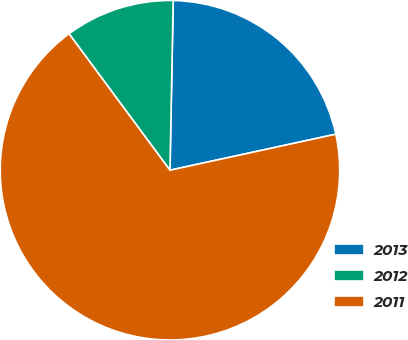Convert chart to OTSL. <chart><loc_0><loc_0><loc_500><loc_500><pie_chart><fcel>2013<fcel>2012<fcel>2011<nl><fcel>21.29%<fcel>10.44%<fcel>68.27%<nl></chart> 